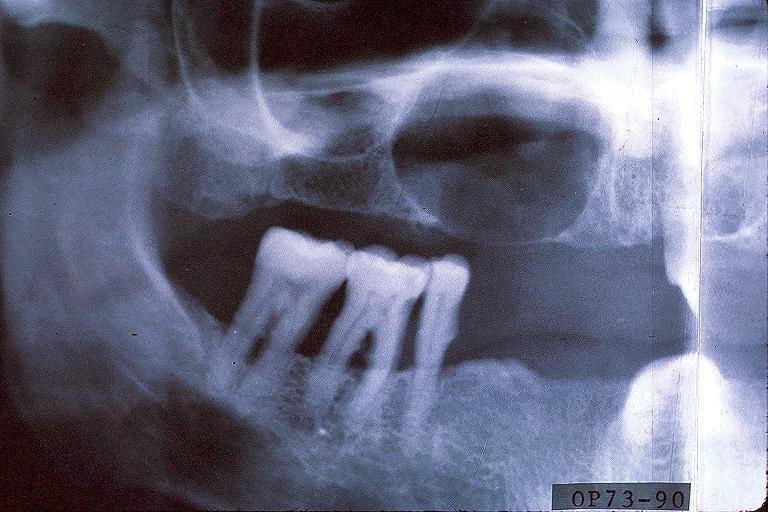where is this?
Answer the question using a single word or phrase. Oral 